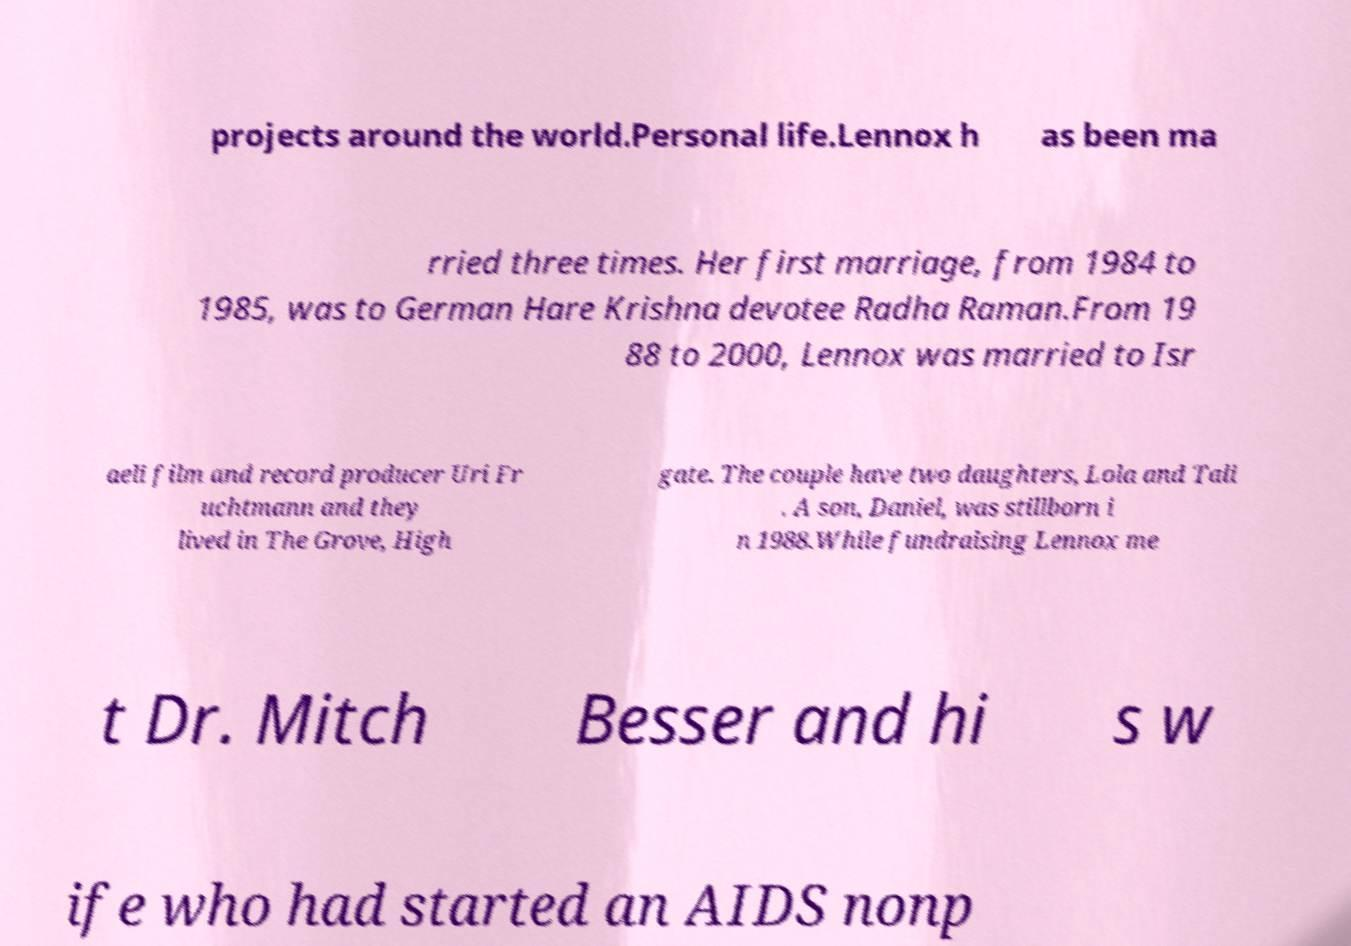What messages or text are displayed in this image? I need them in a readable, typed format. projects around the world.Personal life.Lennox h as been ma rried three times. Her first marriage, from 1984 to 1985, was to German Hare Krishna devotee Radha Raman.From 19 88 to 2000, Lennox was married to Isr aeli film and record producer Uri Fr uchtmann and they lived in The Grove, High gate. The couple have two daughters, Lola and Tali . A son, Daniel, was stillborn i n 1988.While fundraising Lennox me t Dr. Mitch Besser and hi s w ife who had started an AIDS nonp 